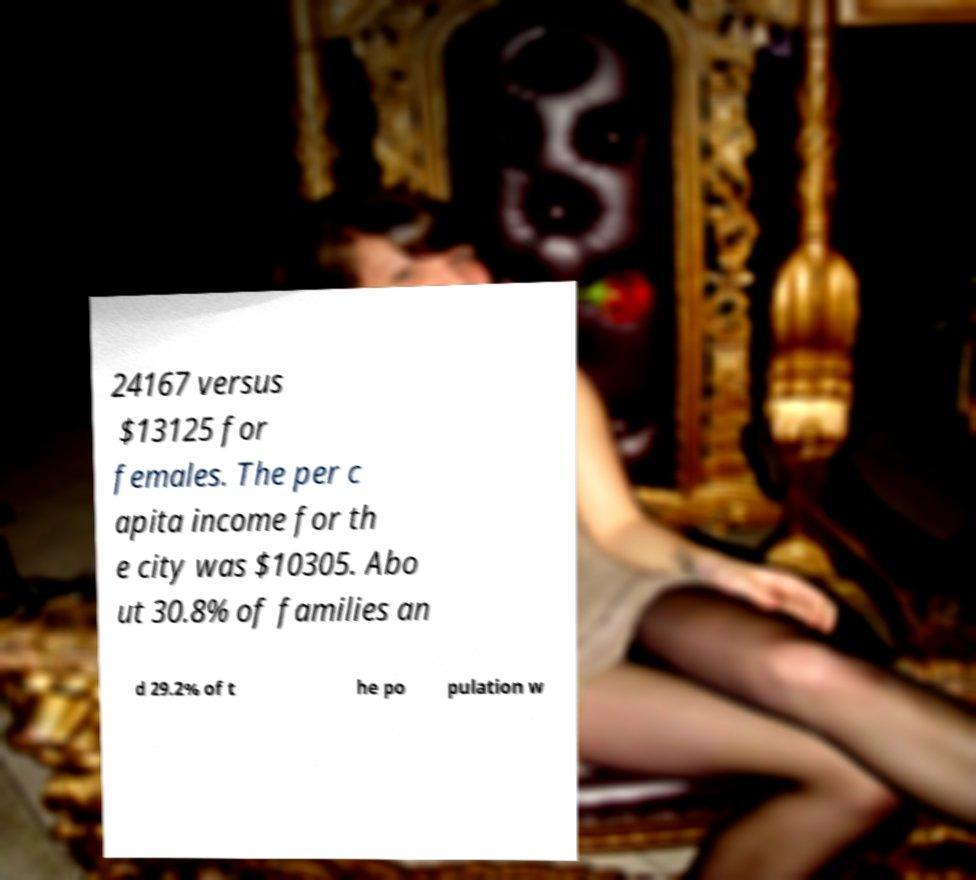For documentation purposes, I need the text within this image transcribed. Could you provide that? 24167 versus $13125 for females. The per c apita income for th e city was $10305. Abo ut 30.8% of families an d 29.2% of t he po pulation w 